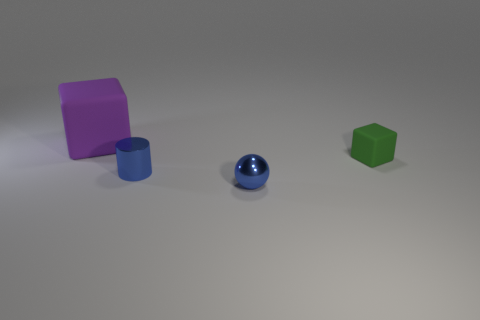There is a object that is the same color as the small cylinder; what is its shape?
Ensure brevity in your answer.  Sphere. The shiny thing that is the same color as the small metallic cylinder is what size?
Ensure brevity in your answer.  Small. Does the metal cylinder have the same size as the ball?
Your answer should be very brief. Yes. What number of other things are there of the same shape as the big rubber object?
Provide a short and direct response. 1. There is a tiny blue thing on the right side of the metallic object behind the blue ball; what is its material?
Make the answer very short. Metal. There is a large purple matte block; are there any tiny cylinders left of it?
Provide a short and direct response. No. Is the size of the ball the same as the rubber thing to the right of the large block?
Offer a terse response. Yes. There is another thing that is the same shape as the big object; what is its size?
Make the answer very short. Small. Are there any other things that are made of the same material as the big thing?
Your response must be concise. Yes. Is the size of the rubber cube in front of the big purple thing the same as the object that is in front of the blue metallic cylinder?
Your response must be concise. Yes. 